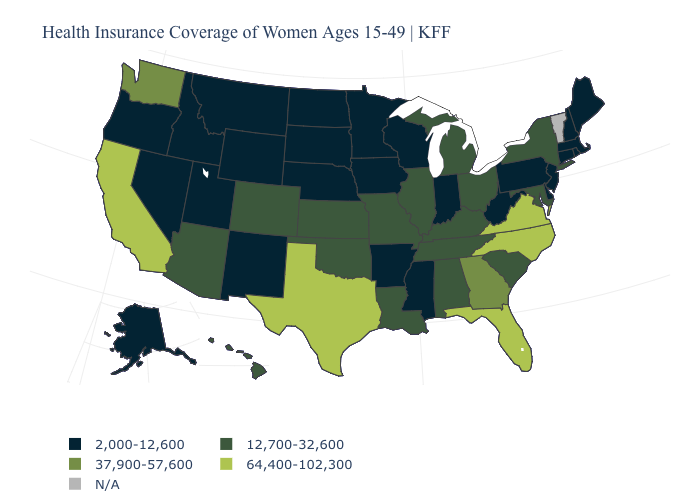What is the highest value in the USA?
Concise answer only. 64,400-102,300. Among the states that border Maine , which have the highest value?
Answer briefly. New Hampshire. What is the lowest value in the USA?
Concise answer only. 2,000-12,600. What is the value of Kansas?
Concise answer only. 12,700-32,600. How many symbols are there in the legend?
Keep it brief. 5. What is the value of Kansas?
Short answer required. 12,700-32,600. Which states have the highest value in the USA?
Quick response, please. California, Florida, North Carolina, Texas, Virginia. Name the states that have a value in the range 2,000-12,600?
Write a very short answer. Alaska, Arkansas, Connecticut, Delaware, Idaho, Indiana, Iowa, Maine, Massachusetts, Minnesota, Mississippi, Montana, Nebraska, Nevada, New Hampshire, New Jersey, New Mexico, North Dakota, Oregon, Pennsylvania, Rhode Island, South Dakota, Utah, West Virginia, Wisconsin, Wyoming. Name the states that have a value in the range N/A?
Give a very brief answer. Vermont. Name the states that have a value in the range 37,900-57,600?
Give a very brief answer. Georgia, Washington. Name the states that have a value in the range 64,400-102,300?
Quick response, please. California, Florida, North Carolina, Texas, Virginia. Name the states that have a value in the range N/A?
Write a very short answer. Vermont. Which states have the highest value in the USA?
Quick response, please. California, Florida, North Carolina, Texas, Virginia. What is the lowest value in the West?
Write a very short answer. 2,000-12,600. 